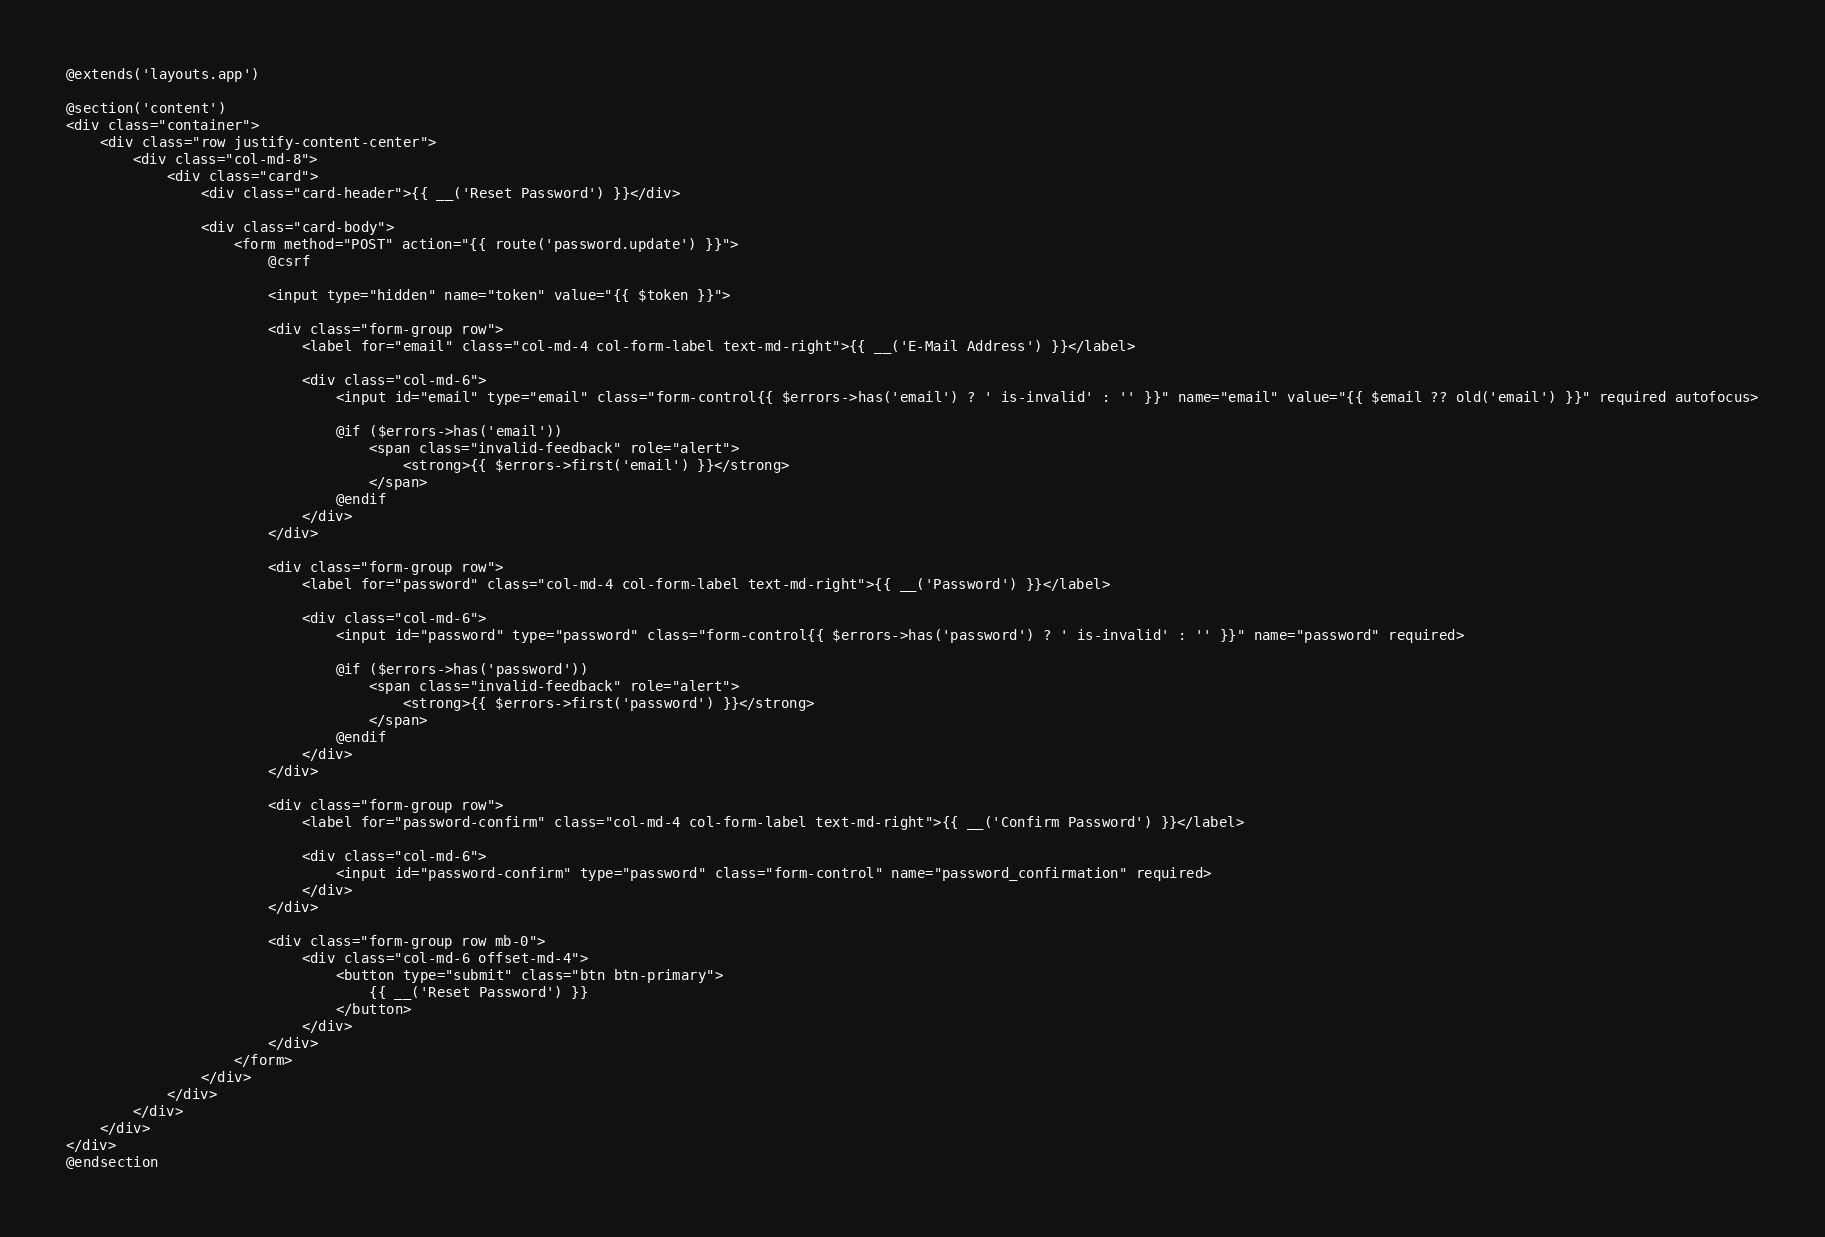Convert code to text. <code><loc_0><loc_0><loc_500><loc_500><_PHP_>@extends('layouts.app')

@section('content')
<div class="container">
    <div class="row justify-content-center">
        <div class="col-md-8">
            <div class="card">
                <div class="card-header">{{ __('Reset Password') }}</div>

                <div class="card-body">
                    <form method="POST" action="{{ route('password.update') }}">
                        @csrf

                        <input type="hidden" name="token" value="{{ $token }}">

                        <div class="form-group row">
                            <label for="email" class="col-md-4 col-form-label text-md-right">{{ __('E-Mail Address') }}</label>

                            <div class="col-md-6">
                                <input id="email" type="email" class="form-control{{ $errors->has('email') ? ' is-invalid' : '' }}" name="email" value="{{ $email ?? old('email') }}" required autofocus>

                                @if ($errors->has('email'))
                                    <span class="invalid-feedback" role="alert">
                                        <strong>{{ $errors->first('email') }}</strong>
                                    </span>
                                @endif
                            </div>
                        </div>

                        <div class="form-group row">
                            <label for="password" class="col-md-4 col-form-label text-md-right">{{ __('Password') }}</label>

                            <div class="col-md-6">
                                <input id="password" type="password" class="form-control{{ $errors->has('password') ? ' is-invalid' : '' }}" name="password" required>

                                @if ($errors->has('password'))
                                    <span class="invalid-feedback" role="alert">
                                        <strong>{{ $errors->first('password') }}</strong>
                                    </span>
                                @endif
                            </div>
                        </div>

                        <div class="form-group row">
                            <label for="password-confirm" class="col-md-4 col-form-label text-md-right">{{ __('Confirm Password') }}</label>

                            <div class="col-md-6">
                                <input id="password-confirm" type="password" class="form-control" name="password_confirmation" required>
                            </div>
                        </div>

                        <div class="form-group row mb-0">
                            <div class="col-md-6 offset-md-4">
                                <button type="submit" class="btn btn-primary">
                                    {{ __('Reset Password') }}
                                </button>
                            </div>
                        </div>
                    </form>
                </div>
            </div>
        </div>
    </div>
</div>
@endsection

</code> 